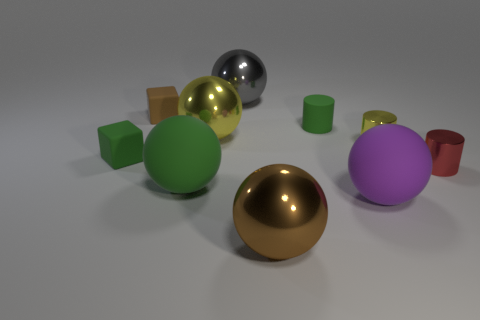Subtract all brown spheres. How many spheres are left? 4 Subtract all purple rubber balls. How many balls are left? 4 Subtract all red balls. Subtract all gray blocks. How many balls are left? 5 Subtract all cylinders. How many objects are left? 7 Add 6 big yellow rubber blocks. How many big yellow rubber blocks exist? 6 Subtract 1 red cylinders. How many objects are left? 9 Subtract all green balls. Subtract all big purple objects. How many objects are left? 8 Add 5 small red metallic objects. How many small red metallic objects are left? 6 